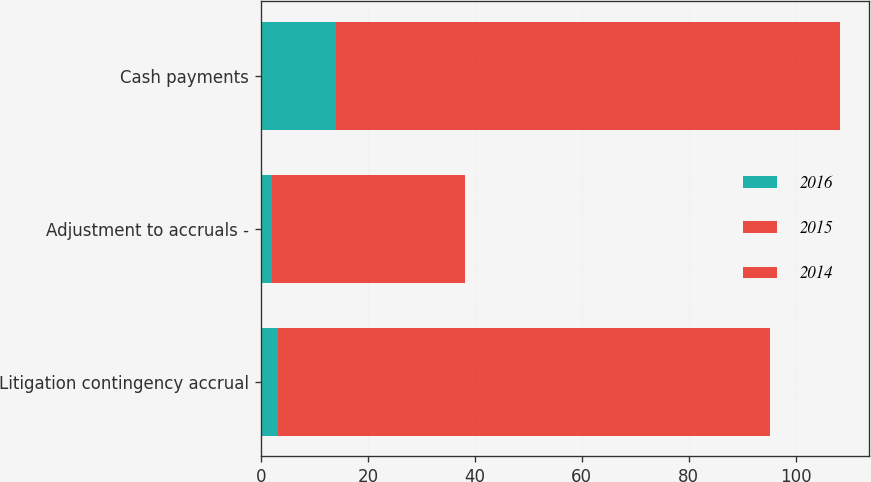Convert chart. <chart><loc_0><loc_0><loc_500><loc_500><stacked_bar_chart><ecel><fcel>Litigation contingency accrual<fcel>Adjustment to accruals -<fcel>Cash payments<nl><fcel>2016<fcel>3.2<fcel>2<fcel>14<nl><fcel>2015<fcel>8.1<fcel>0.7<fcel>82.2<nl><fcel>2014<fcel>83.9<fcel>35.4<fcel>12<nl></chart> 